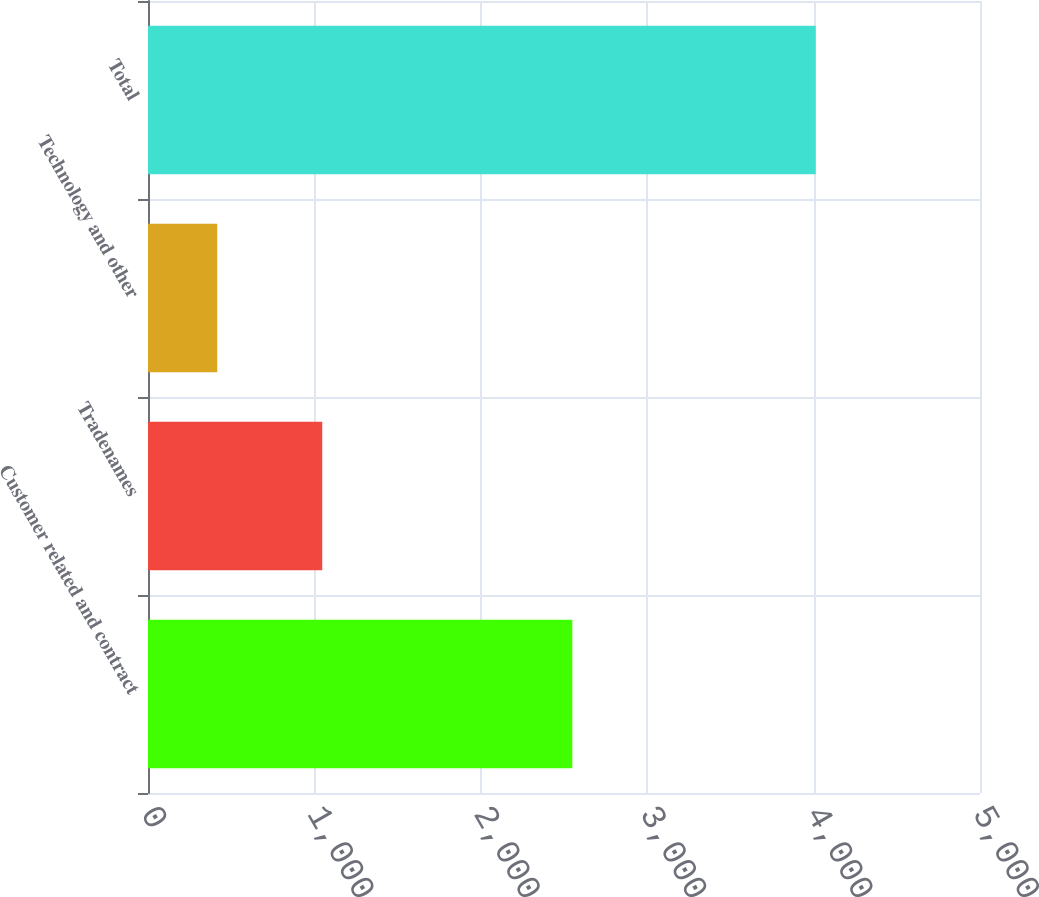Convert chart to OTSL. <chart><loc_0><loc_0><loc_500><loc_500><bar_chart><fcel>Customer related and contract<fcel>Tradenames<fcel>Technology and other<fcel>Total<nl><fcel>2550<fcel>1047<fcel>416<fcel>4013<nl></chart> 